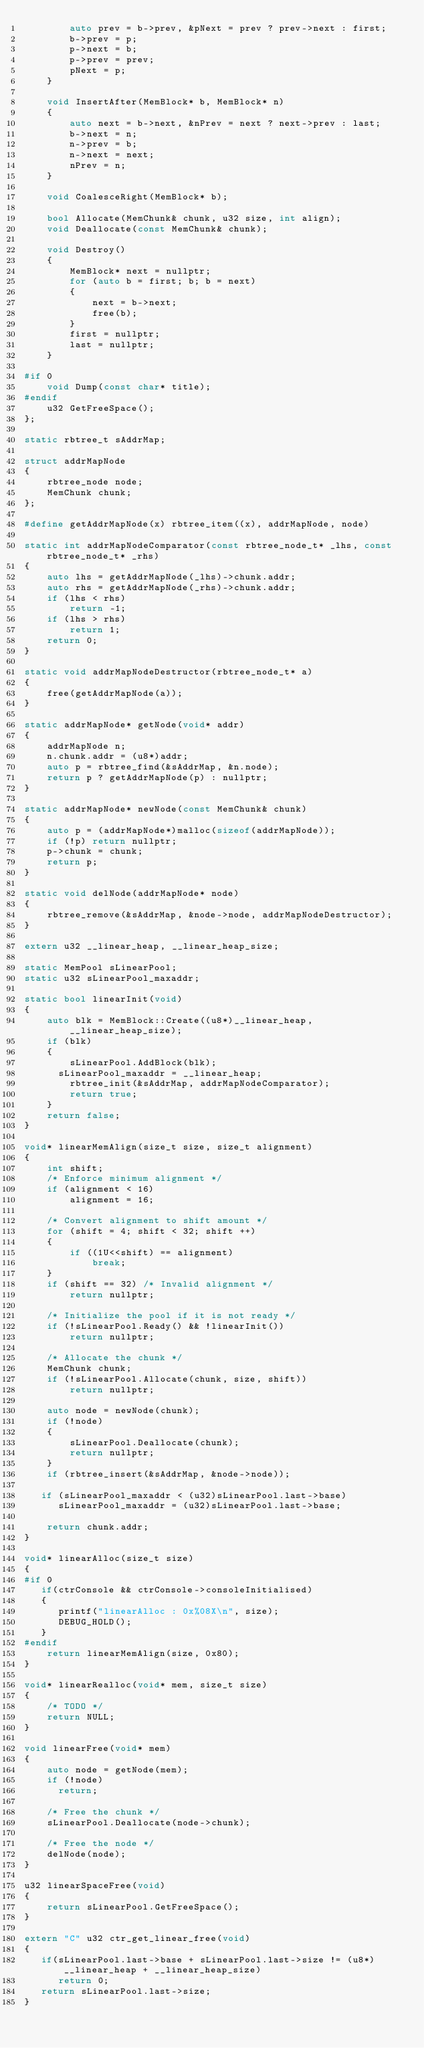<code> <loc_0><loc_0><loc_500><loc_500><_C++_>		auto prev = b->prev, &pNext = prev ? prev->next : first;
		b->prev = p;
		p->next = b;
		p->prev = prev;
		pNext = p;
	}

	void InsertAfter(MemBlock* b, MemBlock* n)
	{
		auto next = b->next, &nPrev = next ? next->prev : last;
		b->next = n;
		n->prev = b;
		n->next = next;
		nPrev = n;
	}

	void CoalesceRight(MemBlock* b);

	bool Allocate(MemChunk& chunk, u32 size, int align);
	void Deallocate(const MemChunk& chunk);

	void Destroy()
	{
		MemBlock* next = nullptr;
		for (auto b = first; b; b = next)
		{
			next = b->next;
			free(b);
		}
		first = nullptr;
		last = nullptr;
	}

#if 0
	void Dump(const char* title);
#endif
	u32 GetFreeSpace();
};

static rbtree_t sAddrMap;

struct addrMapNode
{
	rbtree_node node;
	MemChunk chunk;
};

#define getAddrMapNode(x) rbtree_item((x), addrMapNode, node)

static int addrMapNodeComparator(const rbtree_node_t* _lhs, const rbtree_node_t* _rhs)
{
	auto lhs = getAddrMapNode(_lhs)->chunk.addr;
	auto rhs = getAddrMapNode(_rhs)->chunk.addr;
	if (lhs < rhs)
		return -1;
	if (lhs > rhs)
		return 1;
	return 0;
}

static void addrMapNodeDestructor(rbtree_node_t* a)
{
	free(getAddrMapNode(a));
}

static addrMapNode* getNode(void* addr)
{
	addrMapNode n;
	n.chunk.addr = (u8*)addr;
	auto p = rbtree_find(&sAddrMap, &n.node);
	return p ? getAddrMapNode(p) : nullptr;
}

static addrMapNode* newNode(const MemChunk& chunk)
{
	auto p = (addrMapNode*)malloc(sizeof(addrMapNode));
	if (!p) return nullptr;
	p->chunk = chunk;
	return p;
}

static void delNode(addrMapNode* node)
{
	rbtree_remove(&sAddrMap, &node->node, addrMapNodeDestructor);
}

extern u32 __linear_heap, __linear_heap_size;

static MemPool sLinearPool;
static u32 sLinearPool_maxaddr;

static bool linearInit(void)
{
	auto blk = MemBlock::Create((u8*)__linear_heap, __linear_heap_size);
	if (blk)
	{
		sLinearPool.AddBlock(blk);
      sLinearPool_maxaddr = __linear_heap;
		rbtree_init(&sAddrMap, addrMapNodeComparator);
		return true;
	}
	return false;
}

void* linearMemAlign(size_t size, size_t alignment)
{
	int shift;
	/* Enforce minimum alignment */
	if (alignment < 16)
		alignment = 16;

	/* Convert alignment to shift amount */
	for (shift = 4; shift < 32; shift ++)
	{
		if ((1U<<shift) == alignment)
			break;
	}
	if (shift == 32) /* Invalid alignment */
		return nullptr;

	/* Initialize the pool if it is not ready */
	if (!sLinearPool.Ready() && !linearInit())
		return nullptr;

	/* Allocate the chunk */
	MemChunk chunk;
	if (!sLinearPool.Allocate(chunk, size, shift))
		return nullptr;

	auto node = newNode(chunk);
	if (!node)
	{
		sLinearPool.Deallocate(chunk);
		return nullptr;
	}
	if (rbtree_insert(&sAddrMap, &node->node));

   if (sLinearPool_maxaddr < (u32)sLinearPool.last->base)
      sLinearPool_maxaddr = (u32)sLinearPool.last->base;

	return chunk.addr;
}

void* linearAlloc(size_t size)
{
#if 0
   if(ctrConsole && ctrConsole->consoleInitialised)
   {
      printf("linearAlloc : 0x%08X\n", size);
      DEBUG_HOLD();
   }
#endif
	return linearMemAlign(size, 0x80);
}

void* linearRealloc(void* mem, size_t size)
{
	/* TODO */
	return NULL;
}

void linearFree(void* mem)
{
	auto node = getNode(mem);
	if (!node)
      return;

	/* Free the chunk */
	sLinearPool.Deallocate(node->chunk);

	/* Free the node */
	delNode(node);
}

u32 linearSpaceFree(void)
{
	return sLinearPool.GetFreeSpace();
}

extern "C" u32 ctr_get_linear_free(void)
{
   if(sLinearPool.last->base + sLinearPool.last->size != (u8*)__linear_heap + __linear_heap_size)
      return 0;
   return sLinearPool.last->size;
}
</code> 